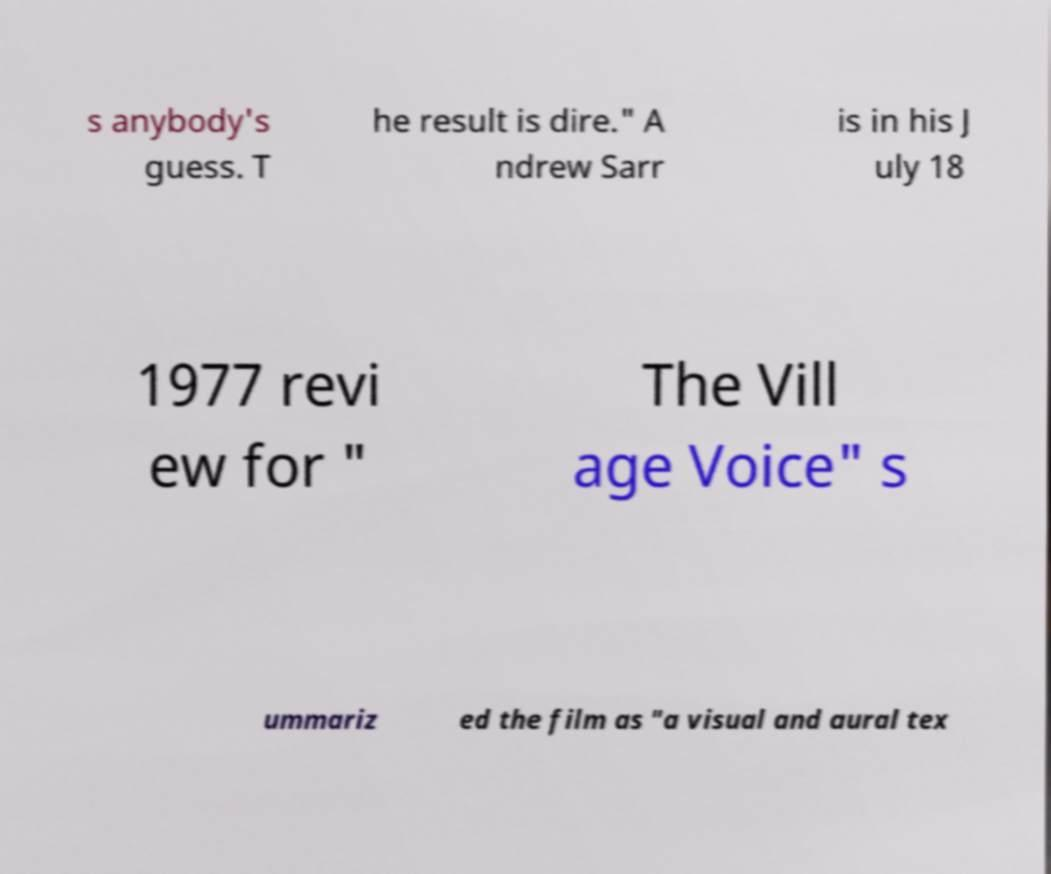Can you accurately transcribe the text from the provided image for me? s anybody's guess. T he result is dire." A ndrew Sarr is in his J uly 18 1977 revi ew for " The Vill age Voice" s ummariz ed the film as "a visual and aural tex 